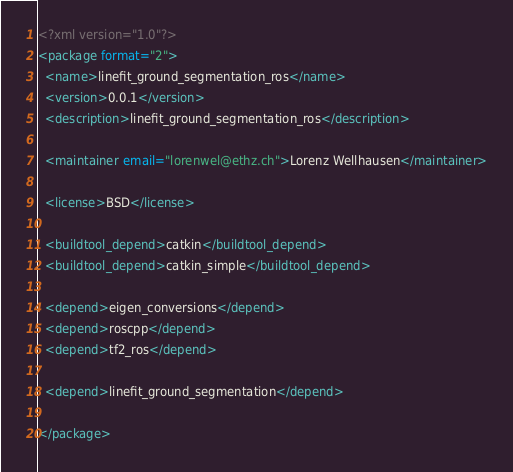<code> <loc_0><loc_0><loc_500><loc_500><_XML_><?xml version="1.0"?>
<package format="2">
  <name>linefit_ground_segmentation_ros</name>
  <version>0.0.1</version>
  <description>linefit_ground_segmentation_ros</description>
  
  <maintainer email="lorenwel@ethz.ch">Lorenz Wellhausen</maintainer>
  
  <license>BSD</license>

  <buildtool_depend>catkin</buildtool_depend>
  <buildtool_depend>catkin_simple</buildtool_depend>
  
  <depend>eigen_conversions</depend>
  <depend>roscpp</depend>  
  <depend>tf2_ros</depend>

  <depend>linefit_ground_segmentation</depend>
  
</package>

</code> 